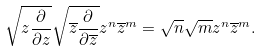Convert formula to latex. <formula><loc_0><loc_0><loc_500><loc_500>\sqrt { z \frac { \partial } { \partial z } } \sqrt { \overline { z } \frac { \partial } { \partial \overline { z } } } z ^ { n } \overline { z } ^ { m } = \sqrt { n } \sqrt { m } z ^ { n } \overline { z } ^ { m } .</formula> 